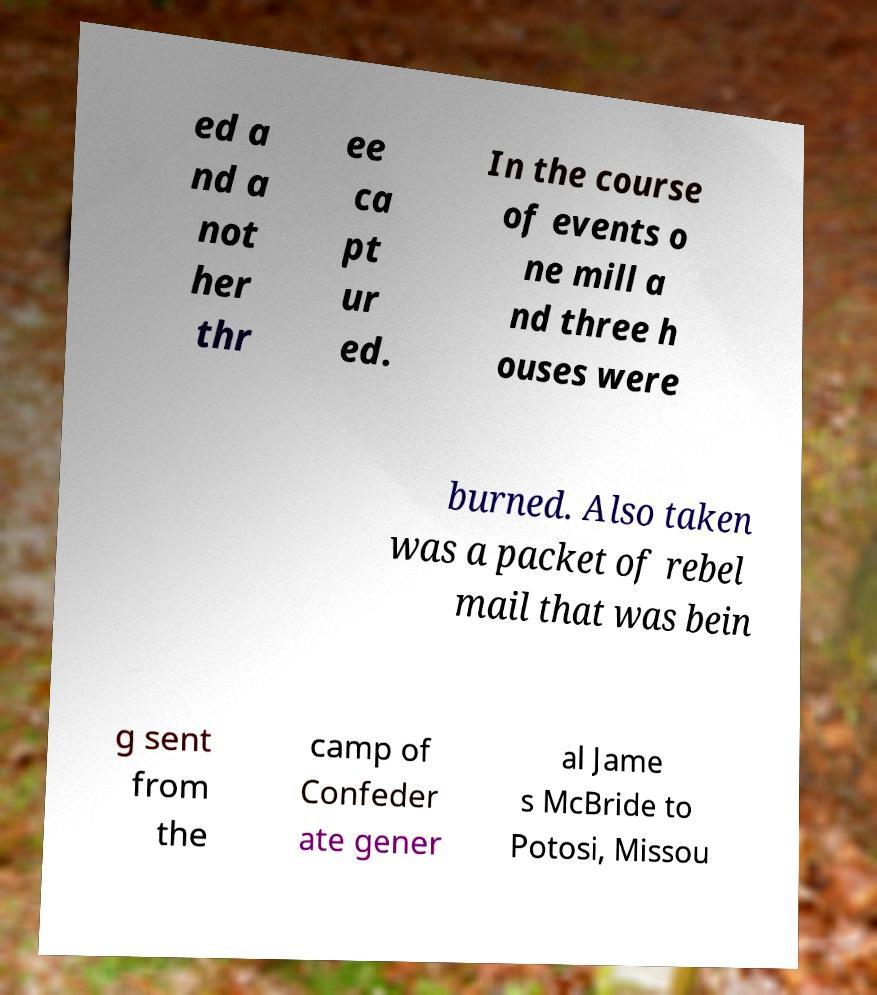Can you read and provide the text displayed in the image?This photo seems to have some interesting text. Can you extract and type it out for me? ed a nd a not her thr ee ca pt ur ed. In the course of events o ne mill a nd three h ouses were burned. Also taken was a packet of rebel mail that was bein g sent from the camp of Confeder ate gener al Jame s McBride to Potosi, Missou 